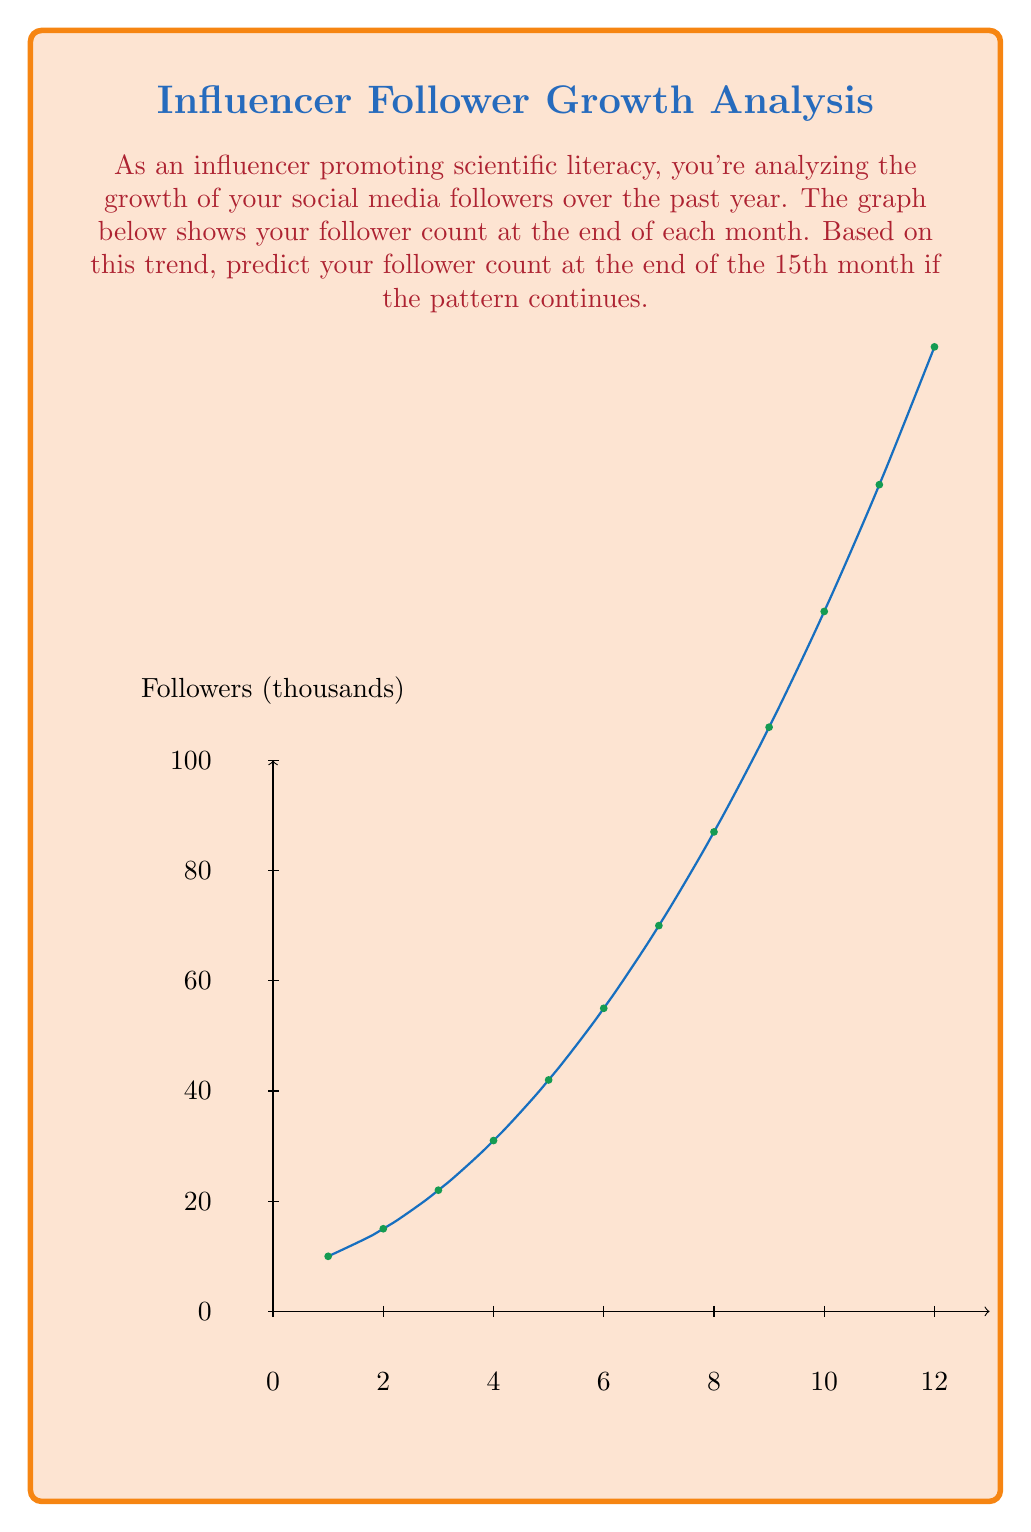Can you answer this question? To predict the follower count for the 15th month, we need to analyze the trend in the data:

1. Observe that the growth is not linear but appears to be exponential.

2. To confirm this, calculate the growth rate between consecutive months:
   Month 1 to 2: 15/10 = 1.5
   Month 2 to 3: 22/15 ≈ 1.47
   Month 3 to 4: 31/22 ≈ 1.41
   ...
   Month 11 to 12: 175/150 ≈ 1.17

3. The growth rate is decreasing, but the absolute increase is growing. This suggests a quadratic growth pattern.

4. Let's fit a quadratic function to the data: $f(x) = ax^2 + bx + c$

5. Using the first, middle, and last points:
   $f(1) = a + b + c = 10$
   $f(6) = 36a + 6b + c = 55$
   $f(12) = 144a + 12b + c = 175$

6. Solving this system of equations (you can use a calculator or computer for this):
   $a ≈ 1.18$, $b ≈ 4.64$, $c ≈ 4.18$

7. Our quadratic function is approximately:
   $f(x) = 1.18x^2 + 4.64x + 4.18$

8. To predict the 15th month, we evaluate $f(15)$:
   $f(15) = 1.18(15^2) + 4.64(15) + 4.18$
          $= 1.18(225) + 69.6 + 4.18$
          $= 265.5 + 69.6 + 4.18$
          $= 339.28$

9. Rounding to the nearest thousand (as the graph uses thousands):
   The predicted follower count for the 15th month is 339,000.
Answer: 339,000 followers 